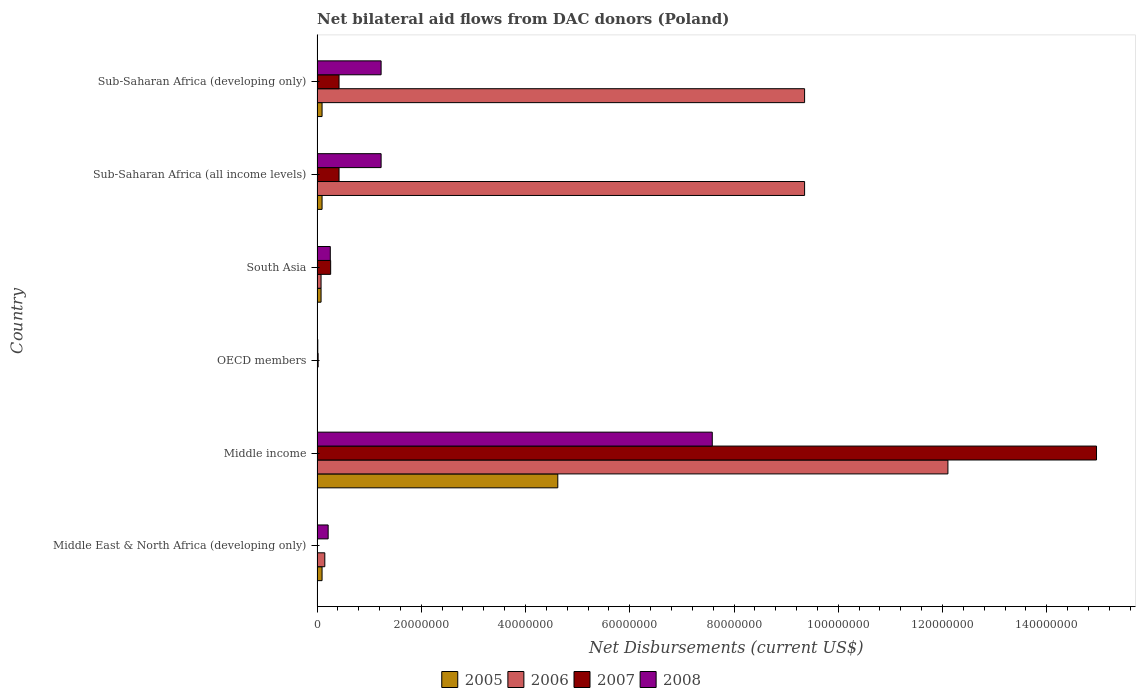How many groups of bars are there?
Provide a short and direct response. 6. Are the number of bars per tick equal to the number of legend labels?
Your answer should be very brief. No. Are the number of bars on each tick of the Y-axis equal?
Your response must be concise. No. How many bars are there on the 1st tick from the bottom?
Provide a short and direct response. 3. What is the label of the 2nd group of bars from the top?
Offer a terse response. Sub-Saharan Africa (all income levels). In how many cases, is the number of bars for a given country not equal to the number of legend labels?
Your answer should be very brief. 1. What is the net bilateral aid flows in 2008 in Sub-Saharan Africa (developing only)?
Keep it short and to the point. 1.23e+07. Across all countries, what is the maximum net bilateral aid flows in 2007?
Provide a short and direct response. 1.50e+08. Across all countries, what is the minimum net bilateral aid flows in 2006?
Your response must be concise. 3.00e+04. What is the total net bilateral aid flows in 2008 in the graph?
Your answer should be compact. 1.05e+08. What is the difference between the net bilateral aid flows in 2008 in Middle income and that in OECD members?
Make the answer very short. 7.57e+07. What is the difference between the net bilateral aid flows in 2006 in South Asia and the net bilateral aid flows in 2008 in Middle income?
Make the answer very short. -7.51e+07. What is the average net bilateral aid flows in 2007 per country?
Your response must be concise. 2.68e+07. What is the difference between the net bilateral aid flows in 2005 and net bilateral aid flows in 2007 in Sub-Saharan Africa (all income levels)?
Make the answer very short. -3.26e+06. In how many countries, is the net bilateral aid flows in 2007 greater than 76000000 US$?
Provide a short and direct response. 1. What is the ratio of the net bilateral aid flows in 2006 in Middle income to that in OECD members?
Your response must be concise. 4034.67. Is the net bilateral aid flows in 2005 in Middle East & North Africa (developing only) less than that in Middle income?
Offer a very short reply. Yes. What is the difference between the highest and the second highest net bilateral aid flows in 2007?
Your response must be concise. 1.45e+08. What is the difference between the highest and the lowest net bilateral aid flows in 2008?
Your answer should be compact. 7.57e+07. Is it the case that in every country, the sum of the net bilateral aid flows in 2006 and net bilateral aid flows in 2008 is greater than the net bilateral aid flows in 2005?
Give a very brief answer. Yes. Are all the bars in the graph horizontal?
Give a very brief answer. Yes. Where does the legend appear in the graph?
Your answer should be compact. Bottom center. What is the title of the graph?
Give a very brief answer. Net bilateral aid flows from DAC donors (Poland). Does "1995" appear as one of the legend labels in the graph?
Provide a short and direct response. No. What is the label or title of the X-axis?
Ensure brevity in your answer.  Net Disbursements (current US$). What is the label or title of the Y-axis?
Ensure brevity in your answer.  Country. What is the Net Disbursements (current US$) in 2005 in Middle East & North Africa (developing only)?
Your answer should be very brief. 9.60e+05. What is the Net Disbursements (current US$) of 2006 in Middle East & North Africa (developing only)?
Provide a short and direct response. 1.49e+06. What is the Net Disbursements (current US$) of 2008 in Middle East & North Africa (developing only)?
Give a very brief answer. 2.13e+06. What is the Net Disbursements (current US$) of 2005 in Middle income?
Offer a terse response. 4.62e+07. What is the Net Disbursements (current US$) of 2006 in Middle income?
Provide a succinct answer. 1.21e+08. What is the Net Disbursements (current US$) of 2007 in Middle income?
Keep it short and to the point. 1.50e+08. What is the Net Disbursements (current US$) of 2008 in Middle income?
Offer a terse response. 7.58e+07. What is the Net Disbursements (current US$) in 2005 in OECD members?
Your answer should be compact. 5.00e+04. What is the Net Disbursements (current US$) in 2006 in OECD members?
Provide a short and direct response. 3.00e+04. What is the Net Disbursements (current US$) in 2008 in OECD members?
Provide a succinct answer. 1.40e+05. What is the Net Disbursements (current US$) of 2005 in South Asia?
Give a very brief answer. 7.70e+05. What is the Net Disbursements (current US$) in 2006 in South Asia?
Keep it short and to the point. 7.70e+05. What is the Net Disbursements (current US$) in 2007 in South Asia?
Provide a succinct answer. 2.61e+06. What is the Net Disbursements (current US$) in 2008 in South Asia?
Your response must be concise. 2.54e+06. What is the Net Disbursements (current US$) of 2005 in Sub-Saharan Africa (all income levels)?
Your answer should be compact. 9.60e+05. What is the Net Disbursements (current US$) in 2006 in Sub-Saharan Africa (all income levels)?
Provide a short and direct response. 9.35e+07. What is the Net Disbursements (current US$) in 2007 in Sub-Saharan Africa (all income levels)?
Keep it short and to the point. 4.22e+06. What is the Net Disbursements (current US$) in 2008 in Sub-Saharan Africa (all income levels)?
Keep it short and to the point. 1.23e+07. What is the Net Disbursements (current US$) of 2005 in Sub-Saharan Africa (developing only)?
Ensure brevity in your answer.  9.60e+05. What is the Net Disbursements (current US$) of 2006 in Sub-Saharan Africa (developing only)?
Your response must be concise. 9.35e+07. What is the Net Disbursements (current US$) in 2007 in Sub-Saharan Africa (developing only)?
Your response must be concise. 4.22e+06. What is the Net Disbursements (current US$) in 2008 in Sub-Saharan Africa (developing only)?
Ensure brevity in your answer.  1.23e+07. Across all countries, what is the maximum Net Disbursements (current US$) in 2005?
Provide a succinct answer. 4.62e+07. Across all countries, what is the maximum Net Disbursements (current US$) in 2006?
Provide a short and direct response. 1.21e+08. Across all countries, what is the maximum Net Disbursements (current US$) in 2007?
Give a very brief answer. 1.50e+08. Across all countries, what is the maximum Net Disbursements (current US$) in 2008?
Give a very brief answer. 7.58e+07. Across all countries, what is the minimum Net Disbursements (current US$) in 2007?
Give a very brief answer. 0. What is the total Net Disbursements (current US$) in 2005 in the graph?
Your response must be concise. 4.99e+07. What is the total Net Disbursements (current US$) in 2006 in the graph?
Your answer should be compact. 3.10e+08. What is the total Net Disbursements (current US$) of 2007 in the graph?
Make the answer very short. 1.61e+08. What is the total Net Disbursements (current US$) in 2008 in the graph?
Offer a very short reply. 1.05e+08. What is the difference between the Net Disbursements (current US$) of 2005 in Middle East & North Africa (developing only) and that in Middle income?
Ensure brevity in your answer.  -4.52e+07. What is the difference between the Net Disbursements (current US$) in 2006 in Middle East & North Africa (developing only) and that in Middle income?
Give a very brief answer. -1.20e+08. What is the difference between the Net Disbursements (current US$) of 2008 in Middle East & North Africa (developing only) and that in Middle income?
Keep it short and to the point. -7.37e+07. What is the difference between the Net Disbursements (current US$) of 2005 in Middle East & North Africa (developing only) and that in OECD members?
Make the answer very short. 9.10e+05. What is the difference between the Net Disbursements (current US$) of 2006 in Middle East & North Africa (developing only) and that in OECD members?
Your answer should be very brief. 1.46e+06. What is the difference between the Net Disbursements (current US$) in 2008 in Middle East & North Africa (developing only) and that in OECD members?
Your answer should be compact. 1.99e+06. What is the difference between the Net Disbursements (current US$) in 2006 in Middle East & North Africa (developing only) and that in South Asia?
Ensure brevity in your answer.  7.20e+05. What is the difference between the Net Disbursements (current US$) of 2008 in Middle East & North Africa (developing only) and that in South Asia?
Your response must be concise. -4.10e+05. What is the difference between the Net Disbursements (current US$) in 2006 in Middle East & North Africa (developing only) and that in Sub-Saharan Africa (all income levels)?
Your response must be concise. -9.20e+07. What is the difference between the Net Disbursements (current US$) in 2008 in Middle East & North Africa (developing only) and that in Sub-Saharan Africa (all income levels)?
Offer a terse response. -1.02e+07. What is the difference between the Net Disbursements (current US$) in 2005 in Middle East & North Africa (developing only) and that in Sub-Saharan Africa (developing only)?
Give a very brief answer. 0. What is the difference between the Net Disbursements (current US$) of 2006 in Middle East & North Africa (developing only) and that in Sub-Saharan Africa (developing only)?
Ensure brevity in your answer.  -9.20e+07. What is the difference between the Net Disbursements (current US$) in 2008 in Middle East & North Africa (developing only) and that in Sub-Saharan Africa (developing only)?
Give a very brief answer. -1.02e+07. What is the difference between the Net Disbursements (current US$) in 2005 in Middle income and that in OECD members?
Give a very brief answer. 4.61e+07. What is the difference between the Net Disbursements (current US$) of 2006 in Middle income and that in OECD members?
Ensure brevity in your answer.  1.21e+08. What is the difference between the Net Disbursements (current US$) in 2007 in Middle income and that in OECD members?
Your response must be concise. 1.49e+08. What is the difference between the Net Disbursements (current US$) of 2008 in Middle income and that in OECD members?
Your answer should be very brief. 7.57e+07. What is the difference between the Net Disbursements (current US$) of 2005 in Middle income and that in South Asia?
Your answer should be compact. 4.54e+07. What is the difference between the Net Disbursements (current US$) in 2006 in Middle income and that in South Asia?
Your response must be concise. 1.20e+08. What is the difference between the Net Disbursements (current US$) in 2007 in Middle income and that in South Asia?
Provide a short and direct response. 1.47e+08. What is the difference between the Net Disbursements (current US$) of 2008 in Middle income and that in South Asia?
Provide a succinct answer. 7.33e+07. What is the difference between the Net Disbursements (current US$) in 2005 in Middle income and that in Sub-Saharan Africa (all income levels)?
Your response must be concise. 4.52e+07. What is the difference between the Net Disbursements (current US$) of 2006 in Middle income and that in Sub-Saharan Africa (all income levels)?
Make the answer very short. 2.75e+07. What is the difference between the Net Disbursements (current US$) in 2007 in Middle income and that in Sub-Saharan Africa (all income levels)?
Make the answer very short. 1.45e+08. What is the difference between the Net Disbursements (current US$) in 2008 in Middle income and that in Sub-Saharan Africa (all income levels)?
Provide a succinct answer. 6.35e+07. What is the difference between the Net Disbursements (current US$) of 2005 in Middle income and that in Sub-Saharan Africa (developing only)?
Keep it short and to the point. 4.52e+07. What is the difference between the Net Disbursements (current US$) in 2006 in Middle income and that in Sub-Saharan Africa (developing only)?
Give a very brief answer. 2.75e+07. What is the difference between the Net Disbursements (current US$) in 2007 in Middle income and that in Sub-Saharan Africa (developing only)?
Your response must be concise. 1.45e+08. What is the difference between the Net Disbursements (current US$) of 2008 in Middle income and that in Sub-Saharan Africa (developing only)?
Ensure brevity in your answer.  6.35e+07. What is the difference between the Net Disbursements (current US$) of 2005 in OECD members and that in South Asia?
Offer a very short reply. -7.20e+05. What is the difference between the Net Disbursements (current US$) in 2006 in OECD members and that in South Asia?
Your answer should be very brief. -7.40e+05. What is the difference between the Net Disbursements (current US$) in 2007 in OECD members and that in South Asia?
Your response must be concise. -2.40e+06. What is the difference between the Net Disbursements (current US$) in 2008 in OECD members and that in South Asia?
Keep it short and to the point. -2.40e+06. What is the difference between the Net Disbursements (current US$) of 2005 in OECD members and that in Sub-Saharan Africa (all income levels)?
Offer a terse response. -9.10e+05. What is the difference between the Net Disbursements (current US$) of 2006 in OECD members and that in Sub-Saharan Africa (all income levels)?
Keep it short and to the point. -9.35e+07. What is the difference between the Net Disbursements (current US$) of 2007 in OECD members and that in Sub-Saharan Africa (all income levels)?
Provide a succinct answer. -4.01e+06. What is the difference between the Net Disbursements (current US$) in 2008 in OECD members and that in Sub-Saharan Africa (all income levels)?
Ensure brevity in your answer.  -1.22e+07. What is the difference between the Net Disbursements (current US$) in 2005 in OECD members and that in Sub-Saharan Africa (developing only)?
Your answer should be compact. -9.10e+05. What is the difference between the Net Disbursements (current US$) of 2006 in OECD members and that in Sub-Saharan Africa (developing only)?
Your answer should be very brief. -9.35e+07. What is the difference between the Net Disbursements (current US$) in 2007 in OECD members and that in Sub-Saharan Africa (developing only)?
Offer a very short reply. -4.01e+06. What is the difference between the Net Disbursements (current US$) in 2008 in OECD members and that in Sub-Saharan Africa (developing only)?
Provide a succinct answer. -1.22e+07. What is the difference between the Net Disbursements (current US$) of 2006 in South Asia and that in Sub-Saharan Africa (all income levels)?
Provide a short and direct response. -9.28e+07. What is the difference between the Net Disbursements (current US$) of 2007 in South Asia and that in Sub-Saharan Africa (all income levels)?
Provide a succinct answer. -1.61e+06. What is the difference between the Net Disbursements (current US$) of 2008 in South Asia and that in Sub-Saharan Africa (all income levels)?
Make the answer very short. -9.75e+06. What is the difference between the Net Disbursements (current US$) of 2006 in South Asia and that in Sub-Saharan Africa (developing only)?
Ensure brevity in your answer.  -9.28e+07. What is the difference between the Net Disbursements (current US$) of 2007 in South Asia and that in Sub-Saharan Africa (developing only)?
Keep it short and to the point. -1.61e+06. What is the difference between the Net Disbursements (current US$) of 2008 in South Asia and that in Sub-Saharan Africa (developing only)?
Give a very brief answer. -9.75e+06. What is the difference between the Net Disbursements (current US$) in 2005 in Sub-Saharan Africa (all income levels) and that in Sub-Saharan Africa (developing only)?
Provide a short and direct response. 0. What is the difference between the Net Disbursements (current US$) of 2006 in Sub-Saharan Africa (all income levels) and that in Sub-Saharan Africa (developing only)?
Your answer should be compact. 0. What is the difference between the Net Disbursements (current US$) of 2005 in Middle East & North Africa (developing only) and the Net Disbursements (current US$) of 2006 in Middle income?
Keep it short and to the point. -1.20e+08. What is the difference between the Net Disbursements (current US$) of 2005 in Middle East & North Africa (developing only) and the Net Disbursements (current US$) of 2007 in Middle income?
Your answer should be compact. -1.49e+08. What is the difference between the Net Disbursements (current US$) in 2005 in Middle East & North Africa (developing only) and the Net Disbursements (current US$) in 2008 in Middle income?
Give a very brief answer. -7.49e+07. What is the difference between the Net Disbursements (current US$) of 2006 in Middle East & North Africa (developing only) and the Net Disbursements (current US$) of 2007 in Middle income?
Ensure brevity in your answer.  -1.48e+08. What is the difference between the Net Disbursements (current US$) in 2006 in Middle East & North Africa (developing only) and the Net Disbursements (current US$) in 2008 in Middle income?
Offer a terse response. -7.43e+07. What is the difference between the Net Disbursements (current US$) of 2005 in Middle East & North Africa (developing only) and the Net Disbursements (current US$) of 2006 in OECD members?
Your answer should be very brief. 9.30e+05. What is the difference between the Net Disbursements (current US$) in 2005 in Middle East & North Africa (developing only) and the Net Disbursements (current US$) in 2007 in OECD members?
Offer a very short reply. 7.50e+05. What is the difference between the Net Disbursements (current US$) in 2005 in Middle East & North Africa (developing only) and the Net Disbursements (current US$) in 2008 in OECD members?
Ensure brevity in your answer.  8.20e+05. What is the difference between the Net Disbursements (current US$) in 2006 in Middle East & North Africa (developing only) and the Net Disbursements (current US$) in 2007 in OECD members?
Your response must be concise. 1.28e+06. What is the difference between the Net Disbursements (current US$) of 2006 in Middle East & North Africa (developing only) and the Net Disbursements (current US$) of 2008 in OECD members?
Provide a short and direct response. 1.35e+06. What is the difference between the Net Disbursements (current US$) in 2005 in Middle East & North Africa (developing only) and the Net Disbursements (current US$) in 2007 in South Asia?
Provide a short and direct response. -1.65e+06. What is the difference between the Net Disbursements (current US$) in 2005 in Middle East & North Africa (developing only) and the Net Disbursements (current US$) in 2008 in South Asia?
Your answer should be compact. -1.58e+06. What is the difference between the Net Disbursements (current US$) in 2006 in Middle East & North Africa (developing only) and the Net Disbursements (current US$) in 2007 in South Asia?
Offer a terse response. -1.12e+06. What is the difference between the Net Disbursements (current US$) of 2006 in Middle East & North Africa (developing only) and the Net Disbursements (current US$) of 2008 in South Asia?
Provide a succinct answer. -1.05e+06. What is the difference between the Net Disbursements (current US$) in 2005 in Middle East & North Africa (developing only) and the Net Disbursements (current US$) in 2006 in Sub-Saharan Africa (all income levels)?
Ensure brevity in your answer.  -9.26e+07. What is the difference between the Net Disbursements (current US$) of 2005 in Middle East & North Africa (developing only) and the Net Disbursements (current US$) of 2007 in Sub-Saharan Africa (all income levels)?
Make the answer very short. -3.26e+06. What is the difference between the Net Disbursements (current US$) in 2005 in Middle East & North Africa (developing only) and the Net Disbursements (current US$) in 2008 in Sub-Saharan Africa (all income levels)?
Keep it short and to the point. -1.13e+07. What is the difference between the Net Disbursements (current US$) of 2006 in Middle East & North Africa (developing only) and the Net Disbursements (current US$) of 2007 in Sub-Saharan Africa (all income levels)?
Your answer should be compact. -2.73e+06. What is the difference between the Net Disbursements (current US$) in 2006 in Middle East & North Africa (developing only) and the Net Disbursements (current US$) in 2008 in Sub-Saharan Africa (all income levels)?
Your answer should be compact. -1.08e+07. What is the difference between the Net Disbursements (current US$) in 2005 in Middle East & North Africa (developing only) and the Net Disbursements (current US$) in 2006 in Sub-Saharan Africa (developing only)?
Offer a terse response. -9.26e+07. What is the difference between the Net Disbursements (current US$) in 2005 in Middle East & North Africa (developing only) and the Net Disbursements (current US$) in 2007 in Sub-Saharan Africa (developing only)?
Provide a succinct answer. -3.26e+06. What is the difference between the Net Disbursements (current US$) of 2005 in Middle East & North Africa (developing only) and the Net Disbursements (current US$) of 2008 in Sub-Saharan Africa (developing only)?
Offer a very short reply. -1.13e+07. What is the difference between the Net Disbursements (current US$) of 2006 in Middle East & North Africa (developing only) and the Net Disbursements (current US$) of 2007 in Sub-Saharan Africa (developing only)?
Give a very brief answer. -2.73e+06. What is the difference between the Net Disbursements (current US$) of 2006 in Middle East & North Africa (developing only) and the Net Disbursements (current US$) of 2008 in Sub-Saharan Africa (developing only)?
Give a very brief answer. -1.08e+07. What is the difference between the Net Disbursements (current US$) in 2005 in Middle income and the Net Disbursements (current US$) in 2006 in OECD members?
Your answer should be compact. 4.62e+07. What is the difference between the Net Disbursements (current US$) of 2005 in Middle income and the Net Disbursements (current US$) of 2007 in OECD members?
Provide a short and direct response. 4.60e+07. What is the difference between the Net Disbursements (current US$) of 2005 in Middle income and the Net Disbursements (current US$) of 2008 in OECD members?
Provide a succinct answer. 4.60e+07. What is the difference between the Net Disbursements (current US$) of 2006 in Middle income and the Net Disbursements (current US$) of 2007 in OECD members?
Offer a very short reply. 1.21e+08. What is the difference between the Net Disbursements (current US$) of 2006 in Middle income and the Net Disbursements (current US$) of 2008 in OECD members?
Provide a short and direct response. 1.21e+08. What is the difference between the Net Disbursements (current US$) in 2007 in Middle income and the Net Disbursements (current US$) in 2008 in OECD members?
Offer a terse response. 1.49e+08. What is the difference between the Net Disbursements (current US$) of 2005 in Middle income and the Net Disbursements (current US$) of 2006 in South Asia?
Your answer should be very brief. 4.54e+07. What is the difference between the Net Disbursements (current US$) of 2005 in Middle income and the Net Disbursements (current US$) of 2007 in South Asia?
Make the answer very short. 4.36e+07. What is the difference between the Net Disbursements (current US$) in 2005 in Middle income and the Net Disbursements (current US$) in 2008 in South Asia?
Offer a very short reply. 4.36e+07. What is the difference between the Net Disbursements (current US$) of 2006 in Middle income and the Net Disbursements (current US$) of 2007 in South Asia?
Give a very brief answer. 1.18e+08. What is the difference between the Net Disbursements (current US$) of 2006 in Middle income and the Net Disbursements (current US$) of 2008 in South Asia?
Ensure brevity in your answer.  1.18e+08. What is the difference between the Net Disbursements (current US$) of 2007 in Middle income and the Net Disbursements (current US$) of 2008 in South Asia?
Offer a very short reply. 1.47e+08. What is the difference between the Net Disbursements (current US$) in 2005 in Middle income and the Net Disbursements (current US$) in 2006 in Sub-Saharan Africa (all income levels)?
Offer a very short reply. -4.74e+07. What is the difference between the Net Disbursements (current US$) in 2005 in Middle income and the Net Disbursements (current US$) in 2007 in Sub-Saharan Africa (all income levels)?
Your answer should be very brief. 4.20e+07. What is the difference between the Net Disbursements (current US$) of 2005 in Middle income and the Net Disbursements (current US$) of 2008 in Sub-Saharan Africa (all income levels)?
Your answer should be very brief. 3.39e+07. What is the difference between the Net Disbursements (current US$) of 2006 in Middle income and the Net Disbursements (current US$) of 2007 in Sub-Saharan Africa (all income levels)?
Ensure brevity in your answer.  1.17e+08. What is the difference between the Net Disbursements (current US$) of 2006 in Middle income and the Net Disbursements (current US$) of 2008 in Sub-Saharan Africa (all income levels)?
Offer a very short reply. 1.09e+08. What is the difference between the Net Disbursements (current US$) of 2007 in Middle income and the Net Disbursements (current US$) of 2008 in Sub-Saharan Africa (all income levels)?
Your answer should be compact. 1.37e+08. What is the difference between the Net Disbursements (current US$) in 2005 in Middle income and the Net Disbursements (current US$) in 2006 in Sub-Saharan Africa (developing only)?
Provide a succinct answer. -4.74e+07. What is the difference between the Net Disbursements (current US$) of 2005 in Middle income and the Net Disbursements (current US$) of 2007 in Sub-Saharan Africa (developing only)?
Make the answer very short. 4.20e+07. What is the difference between the Net Disbursements (current US$) in 2005 in Middle income and the Net Disbursements (current US$) in 2008 in Sub-Saharan Africa (developing only)?
Your answer should be very brief. 3.39e+07. What is the difference between the Net Disbursements (current US$) in 2006 in Middle income and the Net Disbursements (current US$) in 2007 in Sub-Saharan Africa (developing only)?
Your answer should be very brief. 1.17e+08. What is the difference between the Net Disbursements (current US$) in 2006 in Middle income and the Net Disbursements (current US$) in 2008 in Sub-Saharan Africa (developing only)?
Offer a very short reply. 1.09e+08. What is the difference between the Net Disbursements (current US$) of 2007 in Middle income and the Net Disbursements (current US$) of 2008 in Sub-Saharan Africa (developing only)?
Offer a very short reply. 1.37e+08. What is the difference between the Net Disbursements (current US$) in 2005 in OECD members and the Net Disbursements (current US$) in 2006 in South Asia?
Your answer should be very brief. -7.20e+05. What is the difference between the Net Disbursements (current US$) in 2005 in OECD members and the Net Disbursements (current US$) in 2007 in South Asia?
Give a very brief answer. -2.56e+06. What is the difference between the Net Disbursements (current US$) of 2005 in OECD members and the Net Disbursements (current US$) of 2008 in South Asia?
Keep it short and to the point. -2.49e+06. What is the difference between the Net Disbursements (current US$) in 2006 in OECD members and the Net Disbursements (current US$) in 2007 in South Asia?
Offer a very short reply. -2.58e+06. What is the difference between the Net Disbursements (current US$) in 2006 in OECD members and the Net Disbursements (current US$) in 2008 in South Asia?
Offer a terse response. -2.51e+06. What is the difference between the Net Disbursements (current US$) in 2007 in OECD members and the Net Disbursements (current US$) in 2008 in South Asia?
Give a very brief answer. -2.33e+06. What is the difference between the Net Disbursements (current US$) in 2005 in OECD members and the Net Disbursements (current US$) in 2006 in Sub-Saharan Africa (all income levels)?
Your answer should be compact. -9.35e+07. What is the difference between the Net Disbursements (current US$) of 2005 in OECD members and the Net Disbursements (current US$) of 2007 in Sub-Saharan Africa (all income levels)?
Give a very brief answer. -4.17e+06. What is the difference between the Net Disbursements (current US$) in 2005 in OECD members and the Net Disbursements (current US$) in 2008 in Sub-Saharan Africa (all income levels)?
Make the answer very short. -1.22e+07. What is the difference between the Net Disbursements (current US$) in 2006 in OECD members and the Net Disbursements (current US$) in 2007 in Sub-Saharan Africa (all income levels)?
Offer a very short reply. -4.19e+06. What is the difference between the Net Disbursements (current US$) in 2006 in OECD members and the Net Disbursements (current US$) in 2008 in Sub-Saharan Africa (all income levels)?
Provide a succinct answer. -1.23e+07. What is the difference between the Net Disbursements (current US$) of 2007 in OECD members and the Net Disbursements (current US$) of 2008 in Sub-Saharan Africa (all income levels)?
Your answer should be very brief. -1.21e+07. What is the difference between the Net Disbursements (current US$) in 2005 in OECD members and the Net Disbursements (current US$) in 2006 in Sub-Saharan Africa (developing only)?
Your answer should be very brief. -9.35e+07. What is the difference between the Net Disbursements (current US$) of 2005 in OECD members and the Net Disbursements (current US$) of 2007 in Sub-Saharan Africa (developing only)?
Keep it short and to the point. -4.17e+06. What is the difference between the Net Disbursements (current US$) in 2005 in OECD members and the Net Disbursements (current US$) in 2008 in Sub-Saharan Africa (developing only)?
Provide a short and direct response. -1.22e+07. What is the difference between the Net Disbursements (current US$) in 2006 in OECD members and the Net Disbursements (current US$) in 2007 in Sub-Saharan Africa (developing only)?
Provide a short and direct response. -4.19e+06. What is the difference between the Net Disbursements (current US$) in 2006 in OECD members and the Net Disbursements (current US$) in 2008 in Sub-Saharan Africa (developing only)?
Your answer should be compact. -1.23e+07. What is the difference between the Net Disbursements (current US$) of 2007 in OECD members and the Net Disbursements (current US$) of 2008 in Sub-Saharan Africa (developing only)?
Your response must be concise. -1.21e+07. What is the difference between the Net Disbursements (current US$) in 2005 in South Asia and the Net Disbursements (current US$) in 2006 in Sub-Saharan Africa (all income levels)?
Your answer should be very brief. -9.28e+07. What is the difference between the Net Disbursements (current US$) of 2005 in South Asia and the Net Disbursements (current US$) of 2007 in Sub-Saharan Africa (all income levels)?
Offer a terse response. -3.45e+06. What is the difference between the Net Disbursements (current US$) in 2005 in South Asia and the Net Disbursements (current US$) in 2008 in Sub-Saharan Africa (all income levels)?
Offer a terse response. -1.15e+07. What is the difference between the Net Disbursements (current US$) in 2006 in South Asia and the Net Disbursements (current US$) in 2007 in Sub-Saharan Africa (all income levels)?
Offer a very short reply. -3.45e+06. What is the difference between the Net Disbursements (current US$) of 2006 in South Asia and the Net Disbursements (current US$) of 2008 in Sub-Saharan Africa (all income levels)?
Offer a terse response. -1.15e+07. What is the difference between the Net Disbursements (current US$) in 2007 in South Asia and the Net Disbursements (current US$) in 2008 in Sub-Saharan Africa (all income levels)?
Provide a succinct answer. -9.68e+06. What is the difference between the Net Disbursements (current US$) in 2005 in South Asia and the Net Disbursements (current US$) in 2006 in Sub-Saharan Africa (developing only)?
Your answer should be very brief. -9.28e+07. What is the difference between the Net Disbursements (current US$) in 2005 in South Asia and the Net Disbursements (current US$) in 2007 in Sub-Saharan Africa (developing only)?
Offer a terse response. -3.45e+06. What is the difference between the Net Disbursements (current US$) in 2005 in South Asia and the Net Disbursements (current US$) in 2008 in Sub-Saharan Africa (developing only)?
Ensure brevity in your answer.  -1.15e+07. What is the difference between the Net Disbursements (current US$) in 2006 in South Asia and the Net Disbursements (current US$) in 2007 in Sub-Saharan Africa (developing only)?
Keep it short and to the point. -3.45e+06. What is the difference between the Net Disbursements (current US$) of 2006 in South Asia and the Net Disbursements (current US$) of 2008 in Sub-Saharan Africa (developing only)?
Ensure brevity in your answer.  -1.15e+07. What is the difference between the Net Disbursements (current US$) in 2007 in South Asia and the Net Disbursements (current US$) in 2008 in Sub-Saharan Africa (developing only)?
Your answer should be very brief. -9.68e+06. What is the difference between the Net Disbursements (current US$) of 2005 in Sub-Saharan Africa (all income levels) and the Net Disbursements (current US$) of 2006 in Sub-Saharan Africa (developing only)?
Keep it short and to the point. -9.26e+07. What is the difference between the Net Disbursements (current US$) in 2005 in Sub-Saharan Africa (all income levels) and the Net Disbursements (current US$) in 2007 in Sub-Saharan Africa (developing only)?
Offer a terse response. -3.26e+06. What is the difference between the Net Disbursements (current US$) of 2005 in Sub-Saharan Africa (all income levels) and the Net Disbursements (current US$) of 2008 in Sub-Saharan Africa (developing only)?
Provide a short and direct response. -1.13e+07. What is the difference between the Net Disbursements (current US$) of 2006 in Sub-Saharan Africa (all income levels) and the Net Disbursements (current US$) of 2007 in Sub-Saharan Africa (developing only)?
Give a very brief answer. 8.93e+07. What is the difference between the Net Disbursements (current US$) in 2006 in Sub-Saharan Africa (all income levels) and the Net Disbursements (current US$) in 2008 in Sub-Saharan Africa (developing only)?
Your answer should be compact. 8.12e+07. What is the difference between the Net Disbursements (current US$) in 2007 in Sub-Saharan Africa (all income levels) and the Net Disbursements (current US$) in 2008 in Sub-Saharan Africa (developing only)?
Offer a very short reply. -8.07e+06. What is the average Net Disbursements (current US$) in 2005 per country?
Provide a succinct answer. 8.32e+06. What is the average Net Disbursements (current US$) in 2006 per country?
Your answer should be very brief. 5.17e+07. What is the average Net Disbursements (current US$) in 2007 per country?
Provide a succinct answer. 2.68e+07. What is the average Net Disbursements (current US$) in 2008 per country?
Offer a terse response. 1.75e+07. What is the difference between the Net Disbursements (current US$) in 2005 and Net Disbursements (current US$) in 2006 in Middle East & North Africa (developing only)?
Offer a terse response. -5.30e+05. What is the difference between the Net Disbursements (current US$) of 2005 and Net Disbursements (current US$) of 2008 in Middle East & North Africa (developing only)?
Provide a short and direct response. -1.17e+06. What is the difference between the Net Disbursements (current US$) of 2006 and Net Disbursements (current US$) of 2008 in Middle East & North Africa (developing only)?
Your response must be concise. -6.40e+05. What is the difference between the Net Disbursements (current US$) of 2005 and Net Disbursements (current US$) of 2006 in Middle income?
Your answer should be very brief. -7.48e+07. What is the difference between the Net Disbursements (current US$) in 2005 and Net Disbursements (current US$) in 2007 in Middle income?
Offer a terse response. -1.03e+08. What is the difference between the Net Disbursements (current US$) in 2005 and Net Disbursements (current US$) in 2008 in Middle income?
Your answer should be very brief. -2.96e+07. What is the difference between the Net Disbursements (current US$) in 2006 and Net Disbursements (current US$) in 2007 in Middle income?
Make the answer very short. -2.85e+07. What is the difference between the Net Disbursements (current US$) in 2006 and Net Disbursements (current US$) in 2008 in Middle income?
Ensure brevity in your answer.  4.52e+07. What is the difference between the Net Disbursements (current US$) in 2007 and Net Disbursements (current US$) in 2008 in Middle income?
Offer a very short reply. 7.37e+07. What is the difference between the Net Disbursements (current US$) of 2005 and Net Disbursements (current US$) of 2007 in OECD members?
Ensure brevity in your answer.  -1.60e+05. What is the difference between the Net Disbursements (current US$) of 2005 and Net Disbursements (current US$) of 2008 in OECD members?
Your answer should be compact. -9.00e+04. What is the difference between the Net Disbursements (current US$) of 2006 and Net Disbursements (current US$) of 2007 in OECD members?
Your response must be concise. -1.80e+05. What is the difference between the Net Disbursements (current US$) of 2006 and Net Disbursements (current US$) of 2008 in OECD members?
Your answer should be compact. -1.10e+05. What is the difference between the Net Disbursements (current US$) in 2005 and Net Disbursements (current US$) in 2006 in South Asia?
Provide a short and direct response. 0. What is the difference between the Net Disbursements (current US$) of 2005 and Net Disbursements (current US$) of 2007 in South Asia?
Your answer should be very brief. -1.84e+06. What is the difference between the Net Disbursements (current US$) in 2005 and Net Disbursements (current US$) in 2008 in South Asia?
Provide a succinct answer. -1.77e+06. What is the difference between the Net Disbursements (current US$) of 2006 and Net Disbursements (current US$) of 2007 in South Asia?
Offer a terse response. -1.84e+06. What is the difference between the Net Disbursements (current US$) of 2006 and Net Disbursements (current US$) of 2008 in South Asia?
Your response must be concise. -1.77e+06. What is the difference between the Net Disbursements (current US$) in 2005 and Net Disbursements (current US$) in 2006 in Sub-Saharan Africa (all income levels)?
Keep it short and to the point. -9.26e+07. What is the difference between the Net Disbursements (current US$) of 2005 and Net Disbursements (current US$) of 2007 in Sub-Saharan Africa (all income levels)?
Your answer should be very brief. -3.26e+06. What is the difference between the Net Disbursements (current US$) in 2005 and Net Disbursements (current US$) in 2008 in Sub-Saharan Africa (all income levels)?
Ensure brevity in your answer.  -1.13e+07. What is the difference between the Net Disbursements (current US$) of 2006 and Net Disbursements (current US$) of 2007 in Sub-Saharan Africa (all income levels)?
Keep it short and to the point. 8.93e+07. What is the difference between the Net Disbursements (current US$) in 2006 and Net Disbursements (current US$) in 2008 in Sub-Saharan Africa (all income levels)?
Give a very brief answer. 8.12e+07. What is the difference between the Net Disbursements (current US$) of 2007 and Net Disbursements (current US$) of 2008 in Sub-Saharan Africa (all income levels)?
Give a very brief answer. -8.07e+06. What is the difference between the Net Disbursements (current US$) in 2005 and Net Disbursements (current US$) in 2006 in Sub-Saharan Africa (developing only)?
Offer a very short reply. -9.26e+07. What is the difference between the Net Disbursements (current US$) of 2005 and Net Disbursements (current US$) of 2007 in Sub-Saharan Africa (developing only)?
Your response must be concise. -3.26e+06. What is the difference between the Net Disbursements (current US$) in 2005 and Net Disbursements (current US$) in 2008 in Sub-Saharan Africa (developing only)?
Give a very brief answer. -1.13e+07. What is the difference between the Net Disbursements (current US$) in 2006 and Net Disbursements (current US$) in 2007 in Sub-Saharan Africa (developing only)?
Provide a succinct answer. 8.93e+07. What is the difference between the Net Disbursements (current US$) in 2006 and Net Disbursements (current US$) in 2008 in Sub-Saharan Africa (developing only)?
Keep it short and to the point. 8.12e+07. What is the difference between the Net Disbursements (current US$) of 2007 and Net Disbursements (current US$) of 2008 in Sub-Saharan Africa (developing only)?
Make the answer very short. -8.07e+06. What is the ratio of the Net Disbursements (current US$) in 2005 in Middle East & North Africa (developing only) to that in Middle income?
Make the answer very short. 0.02. What is the ratio of the Net Disbursements (current US$) in 2006 in Middle East & North Africa (developing only) to that in Middle income?
Keep it short and to the point. 0.01. What is the ratio of the Net Disbursements (current US$) of 2008 in Middle East & North Africa (developing only) to that in Middle income?
Ensure brevity in your answer.  0.03. What is the ratio of the Net Disbursements (current US$) in 2006 in Middle East & North Africa (developing only) to that in OECD members?
Keep it short and to the point. 49.67. What is the ratio of the Net Disbursements (current US$) in 2008 in Middle East & North Africa (developing only) to that in OECD members?
Make the answer very short. 15.21. What is the ratio of the Net Disbursements (current US$) of 2005 in Middle East & North Africa (developing only) to that in South Asia?
Offer a very short reply. 1.25. What is the ratio of the Net Disbursements (current US$) in 2006 in Middle East & North Africa (developing only) to that in South Asia?
Your answer should be very brief. 1.94. What is the ratio of the Net Disbursements (current US$) of 2008 in Middle East & North Africa (developing only) to that in South Asia?
Your answer should be compact. 0.84. What is the ratio of the Net Disbursements (current US$) of 2006 in Middle East & North Africa (developing only) to that in Sub-Saharan Africa (all income levels)?
Offer a very short reply. 0.02. What is the ratio of the Net Disbursements (current US$) of 2008 in Middle East & North Africa (developing only) to that in Sub-Saharan Africa (all income levels)?
Provide a short and direct response. 0.17. What is the ratio of the Net Disbursements (current US$) in 2005 in Middle East & North Africa (developing only) to that in Sub-Saharan Africa (developing only)?
Keep it short and to the point. 1. What is the ratio of the Net Disbursements (current US$) of 2006 in Middle East & North Africa (developing only) to that in Sub-Saharan Africa (developing only)?
Your response must be concise. 0.02. What is the ratio of the Net Disbursements (current US$) of 2008 in Middle East & North Africa (developing only) to that in Sub-Saharan Africa (developing only)?
Your answer should be very brief. 0.17. What is the ratio of the Net Disbursements (current US$) of 2005 in Middle income to that in OECD members?
Your answer should be compact. 923.8. What is the ratio of the Net Disbursements (current US$) of 2006 in Middle income to that in OECD members?
Your answer should be very brief. 4034.67. What is the ratio of the Net Disbursements (current US$) of 2007 in Middle income to that in OECD members?
Your response must be concise. 712.14. What is the ratio of the Net Disbursements (current US$) in 2008 in Middle income to that in OECD members?
Offer a very short reply. 541.64. What is the ratio of the Net Disbursements (current US$) in 2005 in Middle income to that in South Asia?
Provide a short and direct response. 59.99. What is the ratio of the Net Disbursements (current US$) of 2006 in Middle income to that in South Asia?
Provide a short and direct response. 157.19. What is the ratio of the Net Disbursements (current US$) of 2007 in Middle income to that in South Asia?
Offer a very short reply. 57.3. What is the ratio of the Net Disbursements (current US$) in 2008 in Middle income to that in South Asia?
Give a very brief answer. 29.85. What is the ratio of the Net Disbursements (current US$) of 2005 in Middle income to that in Sub-Saharan Africa (all income levels)?
Your response must be concise. 48.11. What is the ratio of the Net Disbursements (current US$) in 2006 in Middle income to that in Sub-Saharan Africa (all income levels)?
Ensure brevity in your answer.  1.29. What is the ratio of the Net Disbursements (current US$) of 2007 in Middle income to that in Sub-Saharan Africa (all income levels)?
Offer a very short reply. 35.44. What is the ratio of the Net Disbursements (current US$) of 2008 in Middle income to that in Sub-Saharan Africa (all income levels)?
Give a very brief answer. 6.17. What is the ratio of the Net Disbursements (current US$) of 2005 in Middle income to that in Sub-Saharan Africa (developing only)?
Give a very brief answer. 48.11. What is the ratio of the Net Disbursements (current US$) in 2006 in Middle income to that in Sub-Saharan Africa (developing only)?
Offer a very short reply. 1.29. What is the ratio of the Net Disbursements (current US$) in 2007 in Middle income to that in Sub-Saharan Africa (developing only)?
Your answer should be compact. 35.44. What is the ratio of the Net Disbursements (current US$) of 2008 in Middle income to that in Sub-Saharan Africa (developing only)?
Give a very brief answer. 6.17. What is the ratio of the Net Disbursements (current US$) in 2005 in OECD members to that in South Asia?
Give a very brief answer. 0.06. What is the ratio of the Net Disbursements (current US$) of 2006 in OECD members to that in South Asia?
Provide a short and direct response. 0.04. What is the ratio of the Net Disbursements (current US$) of 2007 in OECD members to that in South Asia?
Your answer should be very brief. 0.08. What is the ratio of the Net Disbursements (current US$) of 2008 in OECD members to that in South Asia?
Offer a very short reply. 0.06. What is the ratio of the Net Disbursements (current US$) of 2005 in OECD members to that in Sub-Saharan Africa (all income levels)?
Keep it short and to the point. 0.05. What is the ratio of the Net Disbursements (current US$) of 2006 in OECD members to that in Sub-Saharan Africa (all income levels)?
Offer a very short reply. 0. What is the ratio of the Net Disbursements (current US$) of 2007 in OECD members to that in Sub-Saharan Africa (all income levels)?
Make the answer very short. 0.05. What is the ratio of the Net Disbursements (current US$) of 2008 in OECD members to that in Sub-Saharan Africa (all income levels)?
Your response must be concise. 0.01. What is the ratio of the Net Disbursements (current US$) in 2005 in OECD members to that in Sub-Saharan Africa (developing only)?
Your answer should be compact. 0.05. What is the ratio of the Net Disbursements (current US$) of 2006 in OECD members to that in Sub-Saharan Africa (developing only)?
Keep it short and to the point. 0. What is the ratio of the Net Disbursements (current US$) of 2007 in OECD members to that in Sub-Saharan Africa (developing only)?
Provide a succinct answer. 0.05. What is the ratio of the Net Disbursements (current US$) in 2008 in OECD members to that in Sub-Saharan Africa (developing only)?
Give a very brief answer. 0.01. What is the ratio of the Net Disbursements (current US$) in 2005 in South Asia to that in Sub-Saharan Africa (all income levels)?
Give a very brief answer. 0.8. What is the ratio of the Net Disbursements (current US$) in 2006 in South Asia to that in Sub-Saharan Africa (all income levels)?
Make the answer very short. 0.01. What is the ratio of the Net Disbursements (current US$) in 2007 in South Asia to that in Sub-Saharan Africa (all income levels)?
Make the answer very short. 0.62. What is the ratio of the Net Disbursements (current US$) of 2008 in South Asia to that in Sub-Saharan Africa (all income levels)?
Offer a terse response. 0.21. What is the ratio of the Net Disbursements (current US$) of 2005 in South Asia to that in Sub-Saharan Africa (developing only)?
Give a very brief answer. 0.8. What is the ratio of the Net Disbursements (current US$) of 2006 in South Asia to that in Sub-Saharan Africa (developing only)?
Your response must be concise. 0.01. What is the ratio of the Net Disbursements (current US$) in 2007 in South Asia to that in Sub-Saharan Africa (developing only)?
Ensure brevity in your answer.  0.62. What is the ratio of the Net Disbursements (current US$) of 2008 in South Asia to that in Sub-Saharan Africa (developing only)?
Provide a succinct answer. 0.21. What is the ratio of the Net Disbursements (current US$) of 2006 in Sub-Saharan Africa (all income levels) to that in Sub-Saharan Africa (developing only)?
Offer a very short reply. 1. What is the difference between the highest and the second highest Net Disbursements (current US$) of 2005?
Keep it short and to the point. 4.52e+07. What is the difference between the highest and the second highest Net Disbursements (current US$) of 2006?
Give a very brief answer. 2.75e+07. What is the difference between the highest and the second highest Net Disbursements (current US$) of 2007?
Your response must be concise. 1.45e+08. What is the difference between the highest and the second highest Net Disbursements (current US$) in 2008?
Your answer should be very brief. 6.35e+07. What is the difference between the highest and the lowest Net Disbursements (current US$) of 2005?
Keep it short and to the point. 4.61e+07. What is the difference between the highest and the lowest Net Disbursements (current US$) of 2006?
Your answer should be very brief. 1.21e+08. What is the difference between the highest and the lowest Net Disbursements (current US$) of 2007?
Offer a very short reply. 1.50e+08. What is the difference between the highest and the lowest Net Disbursements (current US$) in 2008?
Make the answer very short. 7.57e+07. 